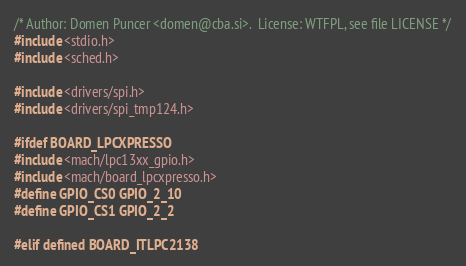<code> <loc_0><loc_0><loc_500><loc_500><_C_>/* Author: Domen Puncer <domen@cba.si>.  License: WTFPL, see file LICENSE */
#include <stdio.h>
#include <sched.h>

#include <drivers/spi.h>
#include <drivers/spi_tmp124.h>

#ifdef BOARD_LPCXPRESSO
#include <mach/lpc13xx_gpio.h>
#include <mach/board_lpcxpresso.h>
#define GPIO_CS0 GPIO_2_10
#define GPIO_CS1 GPIO_2_2

#elif defined BOARD_ITLPC2138</code> 